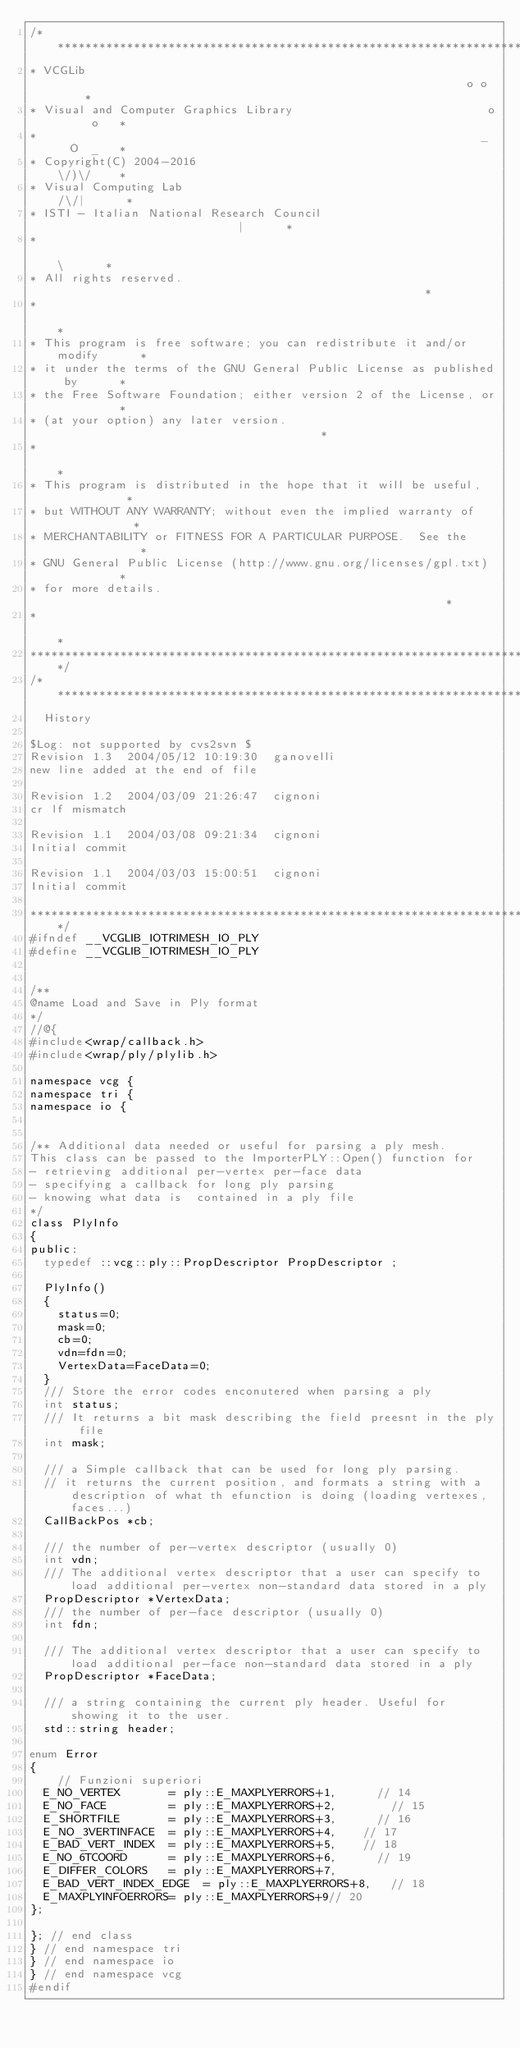Convert code to text. <code><loc_0><loc_0><loc_500><loc_500><_C_>/****************************************************************************
* VCGLib                                                            o o     *
* Visual and Computer Graphics Library                            o     o   *
*                                                                _   O  _   *
* Copyright(C) 2004-2016                                           \/)\/    *
* Visual Computing Lab                                            /\/|      *
* ISTI - Italian National Research Council                           |      *
*                                                                    \      *
* All rights reserved.                                                      *
*                                                                           *
* This program is free software; you can redistribute it and/or modify      *   
* it under the terms of the GNU General Public License as published by      *
* the Free Software Foundation; either version 2 of the License, or         *
* (at your option) any later version.                                       *
*                                                                           *
* This program is distributed in the hope that it will be useful,           *
* but WITHOUT ANY WARRANTY; without even the implied warranty of            *
* MERCHANTABILITY or FITNESS FOR A PARTICULAR PURPOSE.  See the             *
* GNU General Public License (http://www.gnu.org/licenses/gpl.txt)          *
* for more details.                                                         *
*                                                                           *
****************************************************************************/
/****************************************************************************
  History

$Log: not supported by cvs2svn $
Revision 1.3  2004/05/12 10:19:30  ganovelli
new line added at the end of file

Revision 1.2  2004/03/09 21:26:47  cignoni
cr lf mismatch

Revision 1.1  2004/03/08 09:21:34  cignoni
Initial commit

Revision 1.1  2004/03/03 15:00:51  cignoni
Initial commit

****************************************************************************/
#ifndef __VCGLIB_IOTRIMESH_IO_PLY
#define __VCGLIB_IOTRIMESH_IO_PLY


/**
@name Load and Save in Ply format
*/
//@{
#include<wrap/callback.h>
#include<wrap/ply/plylib.h>

namespace vcg {
namespace tri {
namespace io {

  
/** Additional data needed or useful for parsing a ply mesh.
This class can be passed to the ImporterPLY::Open() function for 
- retrieving additional per-vertex per-face data
- specifying a callback for long ply parsing
- knowing what data is  contained in a ply file
*/
class PlyInfo
{
public:
  typedef ::vcg::ply::PropDescriptor PropDescriptor ;

  PlyInfo()
  {
    status=0;
    mask=0;
    cb=0;
    vdn=fdn=0;
    VertexData=FaceData=0;
  }
  /// Store the error codes enconutered when parsing a ply
  int status;
  /// It returns a bit mask describing the field preesnt in the ply file
  int mask;  

  /// a Simple callback that can be used for long ply parsing. 
  // it returns the current position, and formats a string with a description of what th efunction is doing (loading vertexes, faces...)
  CallBackPos *cb;

  /// the number of per-vertex descriptor (usually 0)
  int vdn;
  /// The additional vertex descriptor that a user can specify to load additional per-vertex non-standard data stored in a ply
  PropDescriptor *VertexData;
  /// the number of per-face descriptor (usually 0)
  int fdn;
  
  /// The additional vertex descriptor that a user can specify to load additional per-face non-standard data stored in a ply
  PropDescriptor *FaceData;

  /// a string containing the current ply header. Useful for showing it to the user.
  std::string header;

enum Error
{
		// Funzioni superiori
  E_NO_VERTEX       = ply::E_MAXPLYERRORS+1,			// 14
	E_NO_FACE         = ply::E_MAXPLYERRORS+2,				// 15
	E_SHORTFILE       = ply::E_MAXPLYERRORS+3,			// 16
	E_NO_3VERTINFACE  = ply::E_MAXPLYERRORS+4,		// 17
	E_BAD_VERT_INDEX  = ply::E_MAXPLYERRORS+5,		// 18
	E_NO_6TCOORD      = ply::E_MAXPLYERRORS+6,			// 19
	E_DIFFER_COLORS   = ply::E_MAXPLYERRORS+7,	
	E_BAD_VERT_INDEX_EDGE  = ply::E_MAXPLYERRORS+8,		// 18
  E_MAXPLYINFOERRORS= ply::E_MAXPLYERRORS+9// 20
};

}; // end class
} // end namespace tri
} // end namespace io
} // end namespace vcg
#endif
</code> 